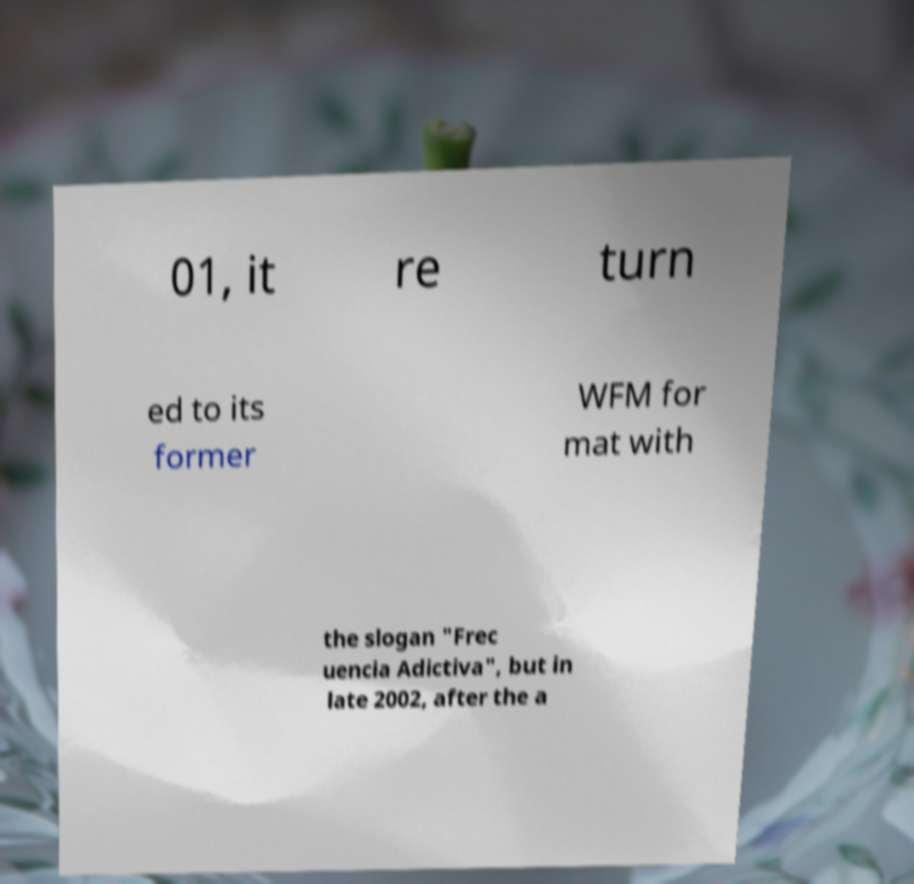Can you read and provide the text displayed in the image?This photo seems to have some interesting text. Can you extract and type it out for me? 01, it re turn ed to its former WFM for mat with the slogan "Frec uencia Adictiva", but in late 2002, after the a 